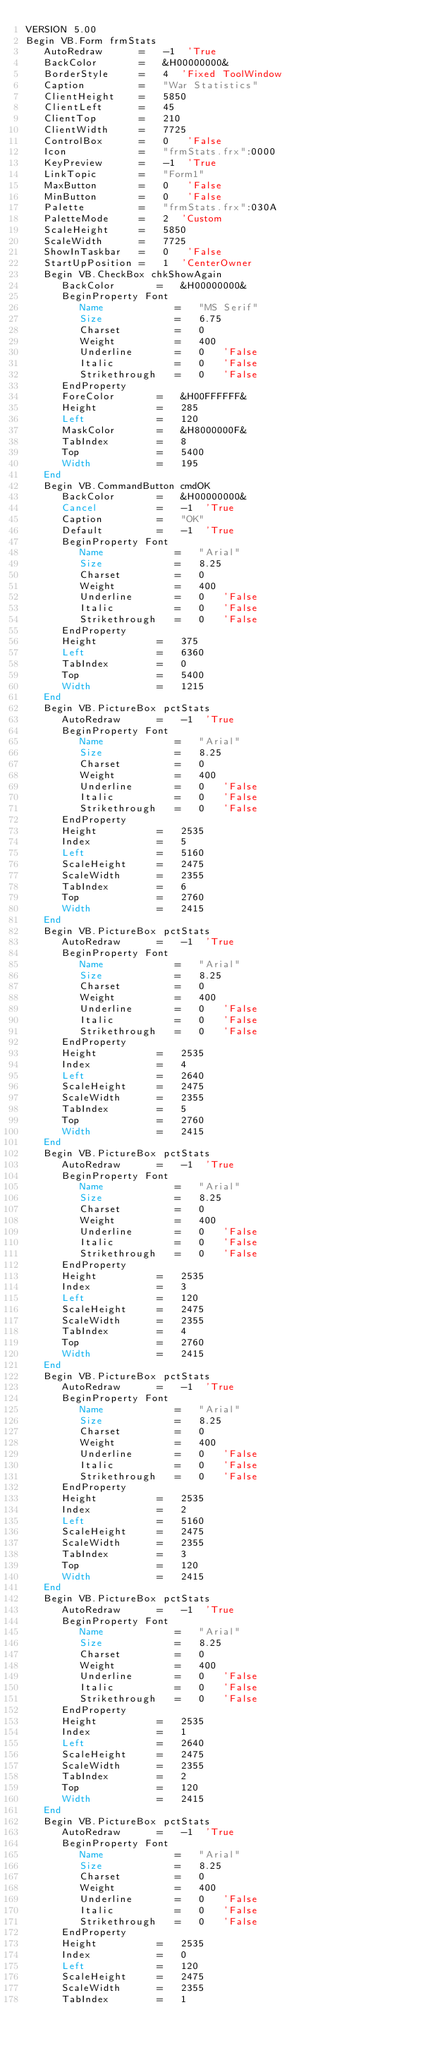<code> <loc_0><loc_0><loc_500><loc_500><_VisualBasic_>VERSION 5.00
Begin VB.Form frmStats 
   AutoRedraw      =   -1  'True
   BackColor       =   &H00000000&
   BorderStyle     =   4  'Fixed ToolWindow
   Caption         =   "War Statistics"
   ClientHeight    =   5850
   ClientLeft      =   45
   ClientTop       =   210
   ClientWidth     =   7725
   ControlBox      =   0   'False
   Icon            =   "frmStats.frx":0000
   KeyPreview      =   -1  'True
   LinkTopic       =   "Form1"
   MaxButton       =   0   'False
   MinButton       =   0   'False
   Palette         =   "frmStats.frx":030A
   PaletteMode     =   2  'Custom
   ScaleHeight     =   5850
   ScaleWidth      =   7725
   ShowInTaskbar   =   0   'False
   StartUpPosition =   1  'CenterOwner
   Begin VB.CheckBox chkShowAgain 
      BackColor       =   &H00000000&
      BeginProperty Font 
         Name            =   "MS Serif"
         Size            =   6.75
         Charset         =   0
         Weight          =   400
         Underline       =   0   'False
         Italic          =   0   'False
         Strikethrough   =   0   'False
      EndProperty
      ForeColor       =   &H00FFFFFF&
      Height          =   285
      Left            =   120
      MaskColor       =   &H8000000F&
      TabIndex        =   8
      Top             =   5400
      Width           =   195
   End
   Begin VB.CommandButton cmdOK 
      BackColor       =   &H00000000&
      Cancel          =   -1  'True
      Caption         =   "OK"
      Default         =   -1  'True
      BeginProperty Font 
         Name            =   "Arial"
         Size            =   8.25
         Charset         =   0
         Weight          =   400
         Underline       =   0   'False
         Italic          =   0   'False
         Strikethrough   =   0   'False
      EndProperty
      Height          =   375
      Left            =   6360
      TabIndex        =   0
      Top             =   5400
      Width           =   1215
   End
   Begin VB.PictureBox pctStats 
      AutoRedraw      =   -1  'True
      BeginProperty Font 
         Name            =   "Arial"
         Size            =   8.25
         Charset         =   0
         Weight          =   400
         Underline       =   0   'False
         Italic          =   0   'False
         Strikethrough   =   0   'False
      EndProperty
      Height          =   2535
      Index           =   5
      Left            =   5160
      ScaleHeight     =   2475
      ScaleWidth      =   2355
      TabIndex        =   6
      Top             =   2760
      Width           =   2415
   End
   Begin VB.PictureBox pctStats 
      AutoRedraw      =   -1  'True
      BeginProperty Font 
         Name            =   "Arial"
         Size            =   8.25
         Charset         =   0
         Weight          =   400
         Underline       =   0   'False
         Italic          =   0   'False
         Strikethrough   =   0   'False
      EndProperty
      Height          =   2535
      Index           =   4
      Left            =   2640
      ScaleHeight     =   2475
      ScaleWidth      =   2355
      TabIndex        =   5
      Top             =   2760
      Width           =   2415
   End
   Begin VB.PictureBox pctStats 
      AutoRedraw      =   -1  'True
      BeginProperty Font 
         Name            =   "Arial"
         Size            =   8.25
         Charset         =   0
         Weight          =   400
         Underline       =   0   'False
         Italic          =   0   'False
         Strikethrough   =   0   'False
      EndProperty
      Height          =   2535
      Index           =   3
      Left            =   120
      ScaleHeight     =   2475
      ScaleWidth      =   2355
      TabIndex        =   4
      Top             =   2760
      Width           =   2415
   End
   Begin VB.PictureBox pctStats 
      AutoRedraw      =   -1  'True
      BeginProperty Font 
         Name            =   "Arial"
         Size            =   8.25
         Charset         =   0
         Weight          =   400
         Underline       =   0   'False
         Italic          =   0   'False
         Strikethrough   =   0   'False
      EndProperty
      Height          =   2535
      Index           =   2
      Left            =   5160
      ScaleHeight     =   2475
      ScaleWidth      =   2355
      TabIndex        =   3
      Top             =   120
      Width           =   2415
   End
   Begin VB.PictureBox pctStats 
      AutoRedraw      =   -1  'True
      BeginProperty Font 
         Name            =   "Arial"
         Size            =   8.25
         Charset         =   0
         Weight          =   400
         Underline       =   0   'False
         Italic          =   0   'False
         Strikethrough   =   0   'False
      EndProperty
      Height          =   2535
      Index           =   1
      Left            =   2640
      ScaleHeight     =   2475
      ScaleWidth      =   2355
      TabIndex        =   2
      Top             =   120
      Width           =   2415
   End
   Begin VB.PictureBox pctStats 
      AutoRedraw      =   -1  'True
      BeginProperty Font 
         Name            =   "Arial"
         Size            =   8.25
         Charset         =   0
         Weight          =   400
         Underline       =   0   'False
         Italic          =   0   'False
         Strikethrough   =   0   'False
      EndProperty
      Height          =   2535
      Index           =   0
      Left            =   120
      ScaleHeight     =   2475
      ScaleWidth      =   2355
      TabIndex        =   1</code> 